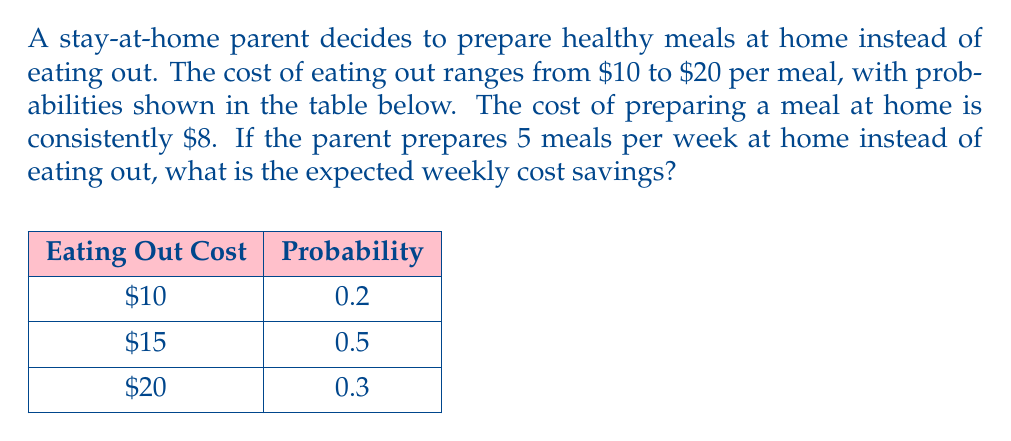Solve this math problem. To solve this problem, we'll follow these steps:

1. Calculate the expected cost of eating out for one meal:
   $$E(\text{eating out}) = 10 \cdot 0.2 + 15 \cdot 0.5 + 20 \cdot 0.3 = 2 + 7.5 + 6 = 15.5$$

2. Calculate the cost difference between eating out and cooking at home for one meal:
   $$\text{Difference} = E(\text{eating out}) - \text{Cost of home-cooked meal}$$
   $$\text{Difference} = 15.5 - 8 = 7.5$$

3. Calculate the expected weekly savings for 5 meals:
   $$\text{Weekly savings} = 5 \cdot \text{Difference} = 5 \cdot 7.5 = 37.5$$

Therefore, the expected weekly cost savings is $37.50.
Answer: $37.50 